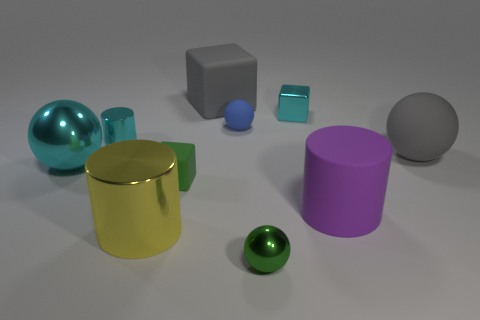Is the color of the large matte ball the same as the big matte block?
Give a very brief answer. Yes. Do the tiny cube right of the green cube and the large gray thing behind the big gray rubber sphere have the same material?
Provide a succinct answer. No. How many objects are either tiny shiny objects or matte blocks behind the tiny rubber block?
Your response must be concise. 4. There is a rubber object that is the same color as the large cube; what is its shape?
Offer a terse response. Sphere. What is the blue object made of?
Keep it short and to the point. Rubber. Does the cyan block have the same material as the gray ball?
Offer a very short reply. No. How many shiny things are big cyan things or small cylinders?
Your answer should be very brief. 2. What shape is the small thing that is in front of the small matte block?
Your answer should be very brief. Sphere. There is a cylinder that is the same material as the large block; what size is it?
Your answer should be very brief. Large. There is a shiny object that is on the right side of the small blue ball and in front of the large rubber sphere; what is its shape?
Your response must be concise. Sphere. 